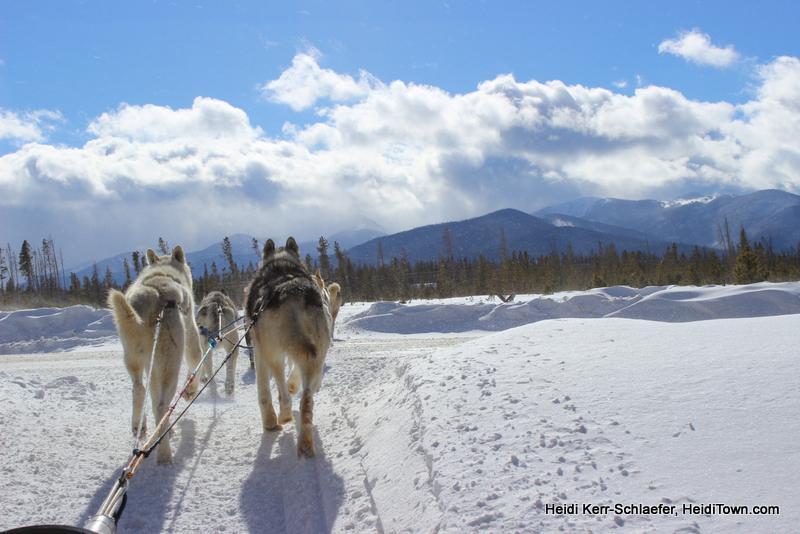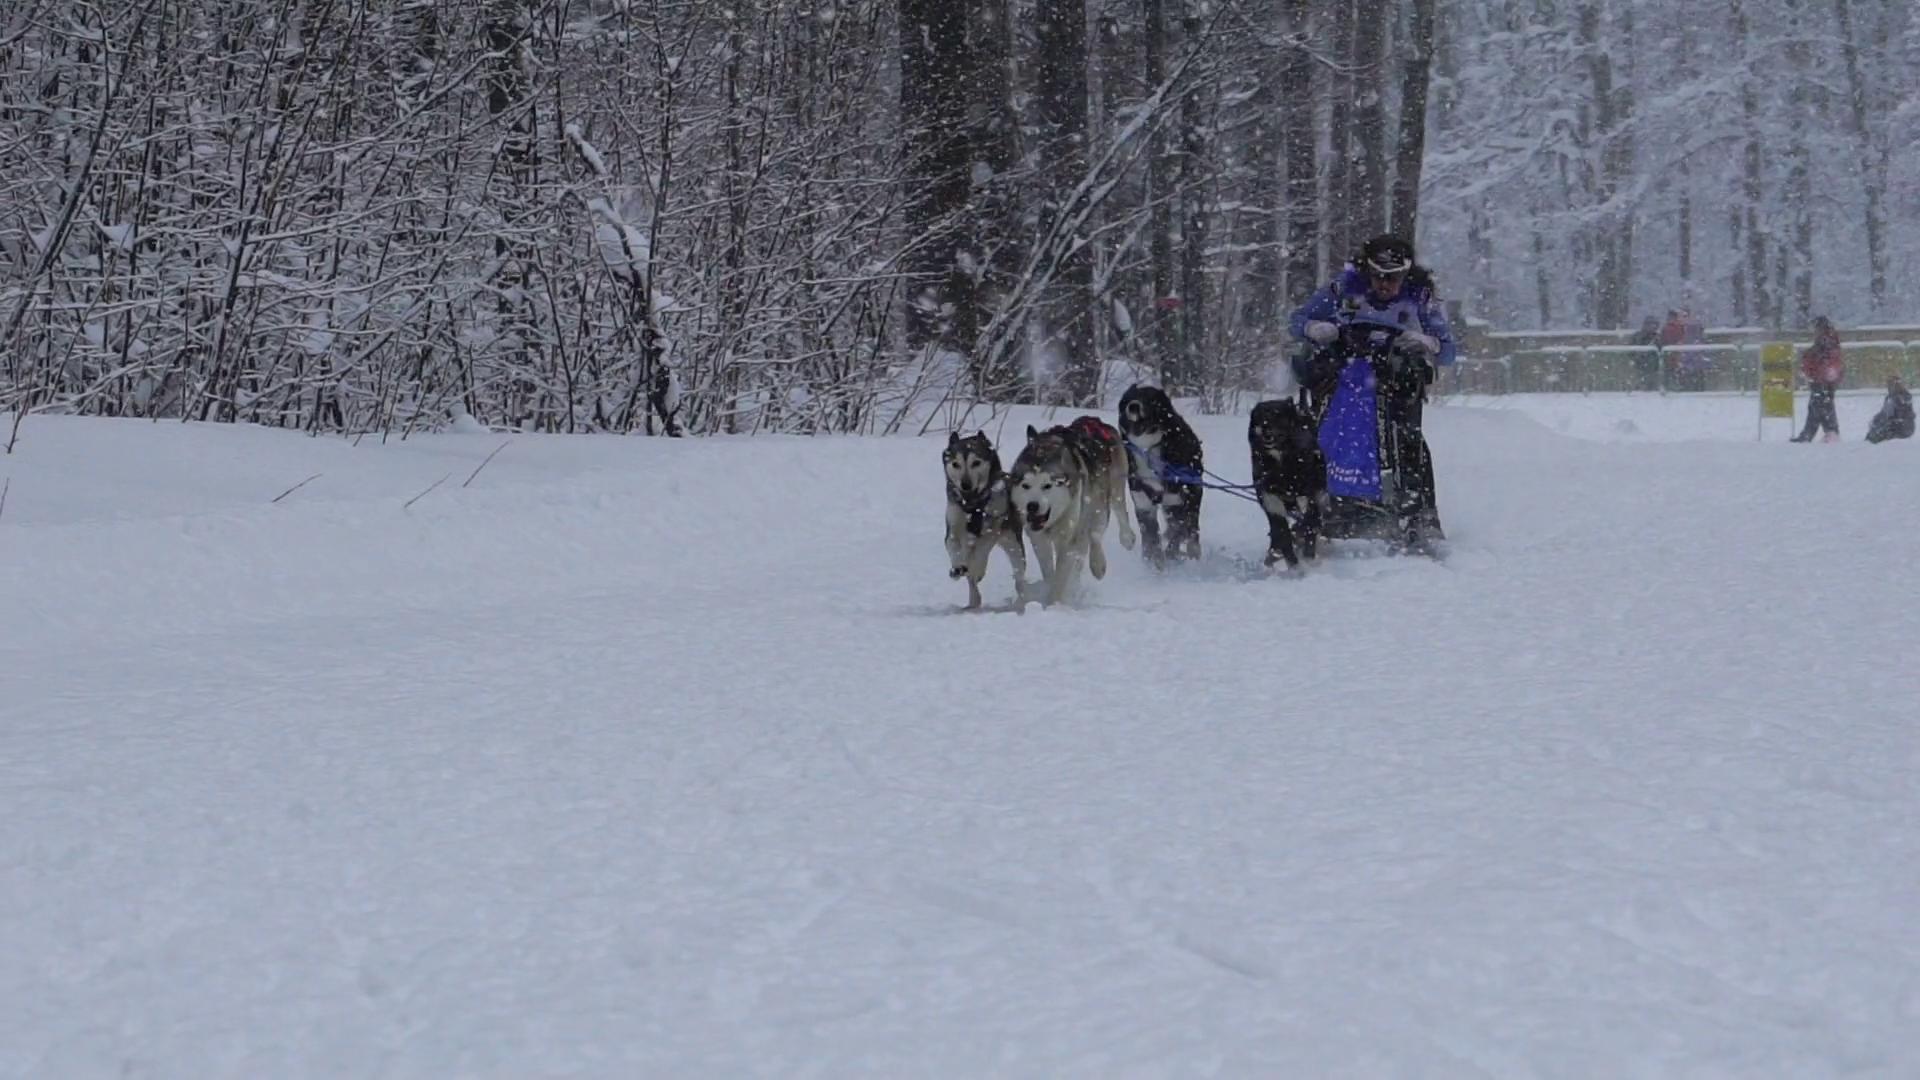The first image is the image on the left, the second image is the image on the right. Evaluate the accuracy of this statement regarding the images: "One image shows a team of dogs heading away from the camera toward a background of mountains.". Is it true? Answer yes or no. Yes. The first image is the image on the left, the second image is the image on the right. Analyze the images presented: Is the assertion "In one of the images, at least one dog on a leash is anchored to the waist of a person on skis." valid? Answer yes or no. No. 